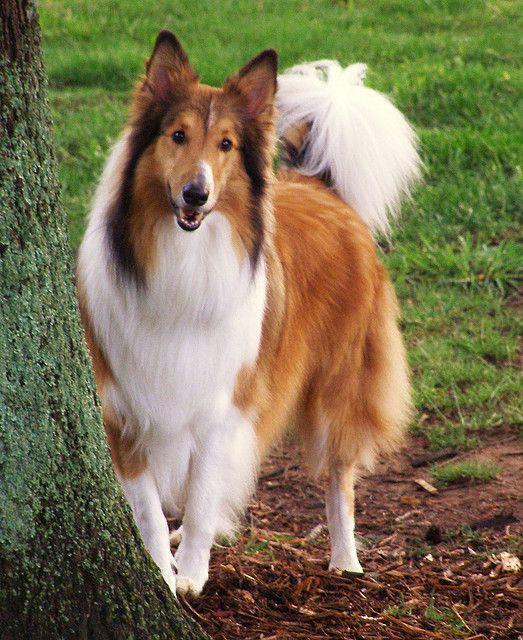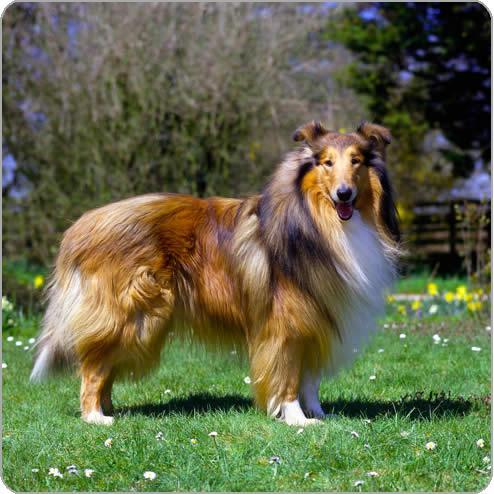The first image is the image on the left, the second image is the image on the right. For the images displayed, is the sentence "One fluffy dog is standing in the grass near flowers." factually correct? Answer yes or no. Yes. The first image is the image on the left, the second image is the image on the right. Evaluate the accuracy of this statement regarding the images: "in at least one image there is a dog standing in the grass". Is it true? Answer yes or no. Yes. 